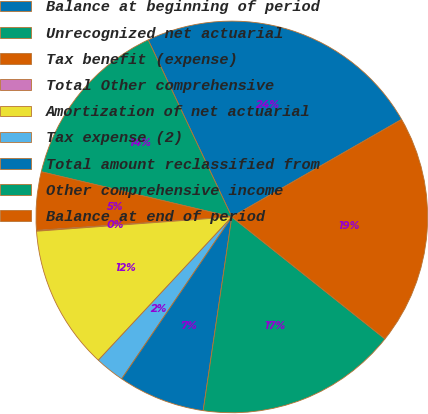Convert chart to OTSL. <chart><loc_0><loc_0><loc_500><loc_500><pie_chart><fcel>Balance at beginning of period<fcel>Unrecognized net actuarial<fcel>Tax benefit (expense)<fcel>Total Other comprehensive<fcel>Amortization of net actuarial<fcel>Tax expense (2)<fcel>Total amount reclassified from<fcel>Other comprehensive income<fcel>Balance at end of period<nl><fcel>23.73%<fcel>14.27%<fcel>4.8%<fcel>0.07%<fcel>11.9%<fcel>2.43%<fcel>7.17%<fcel>16.63%<fcel>19.0%<nl></chart> 